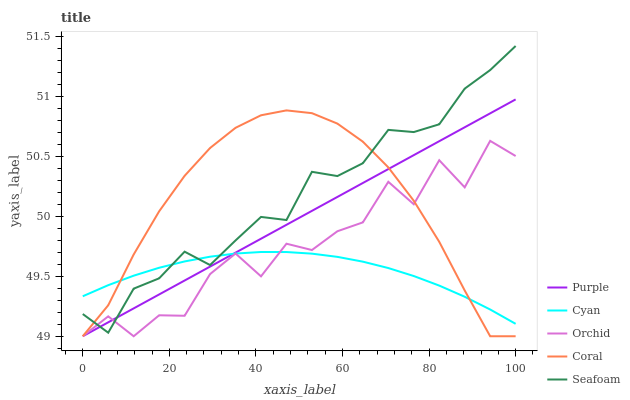Does Cyan have the minimum area under the curve?
Answer yes or no. Yes. Does Seafoam have the maximum area under the curve?
Answer yes or no. Yes. Does Coral have the minimum area under the curve?
Answer yes or no. No. Does Coral have the maximum area under the curve?
Answer yes or no. No. Is Purple the smoothest?
Answer yes or no. Yes. Is Orchid the roughest?
Answer yes or no. Yes. Is Cyan the smoothest?
Answer yes or no. No. Is Cyan the roughest?
Answer yes or no. No. Does Purple have the lowest value?
Answer yes or no. Yes. Does Cyan have the lowest value?
Answer yes or no. No. Does Seafoam have the highest value?
Answer yes or no. Yes. Does Coral have the highest value?
Answer yes or no. No. Does Cyan intersect Orchid?
Answer yes or no. Yes. Is Cyan less than Orchid?
Answer yes or no. No. Is Cyan greater than Orchid?
Answer yes or no. No. 